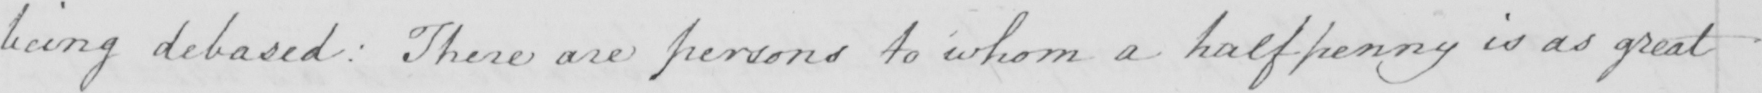Transcribe the text shown in this historical manuscript line. being debased :  There are persons to whom a halfpenny is as great 